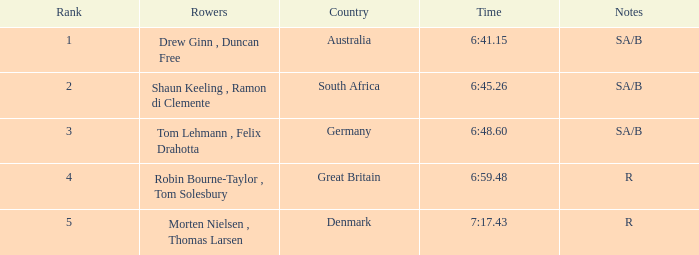What was the paramount level for rowers who represented denmark? 5.0. 